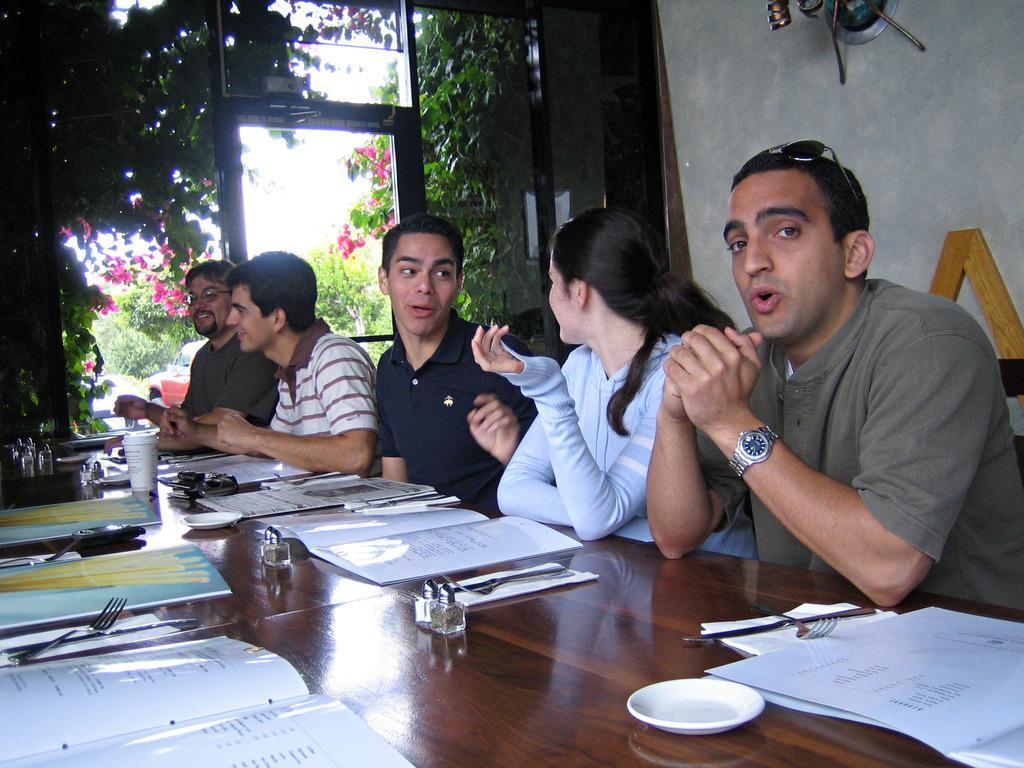In one or two sentences, can you explain what this image depicts? In this picture we can see five persons sitting on chair and in front of them there is table and on table we can see books, forks, knife, tissue paper, bottles, plate, glass and in the background we can see window, tree, wall. 